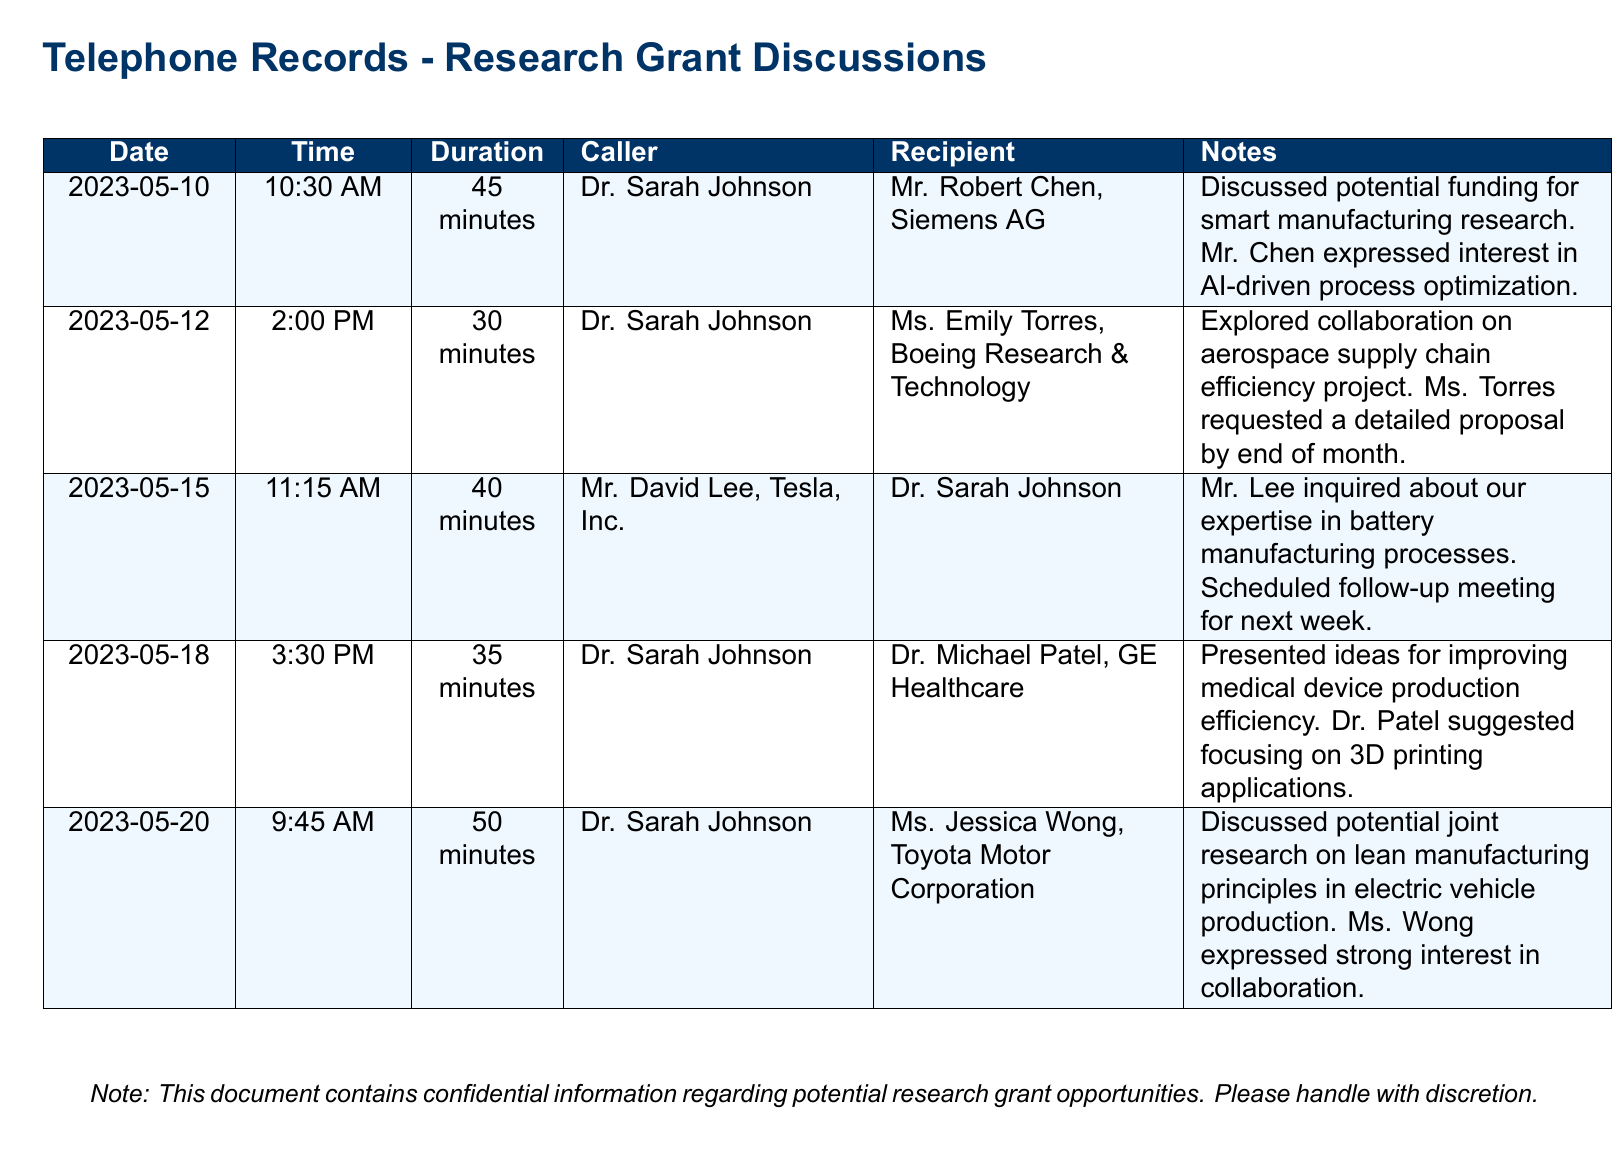What is the duration of the call on May 10? The duration of the call on May 10 is specified in the document as 45 minutes.
Answer: 45 minutes Who called Mr. Robert Chen? The document states that Dr. Sarah Johnson is the caller who contacted Mr. Robert Chen.
Answer: Dr. Sarah Johnson What organization is Ms. Emily Torres associated with? The document indicates that Ms. Emily Torres is associated with Boeing Research & Technology.
Answer: Boeing Research & Technology What was discussed in the call with Dr. Michael Patel? The call with Dr. Michael Patel involved presenting ideas for improving medical device production efficiency.
Answer: Improving medical device production efficiency When is the follow-up meeting with Mr. David Lee scheduled? The document notes that a follow-up meeting was scheduled for next week after the call on May 15.
Answer: Next week Which company expressed strong interest in collaboration on lean manufacturing? According to the document, Toyota Motor Corporation expressed strong interest in collaboration on lean manufacturing principles.
Answer: Toyota Motor Corporation How many minutes was the call on May 12? The call on May 12 lasted for 30 minutes, as provided in the document.
Answer: 30 minutes 